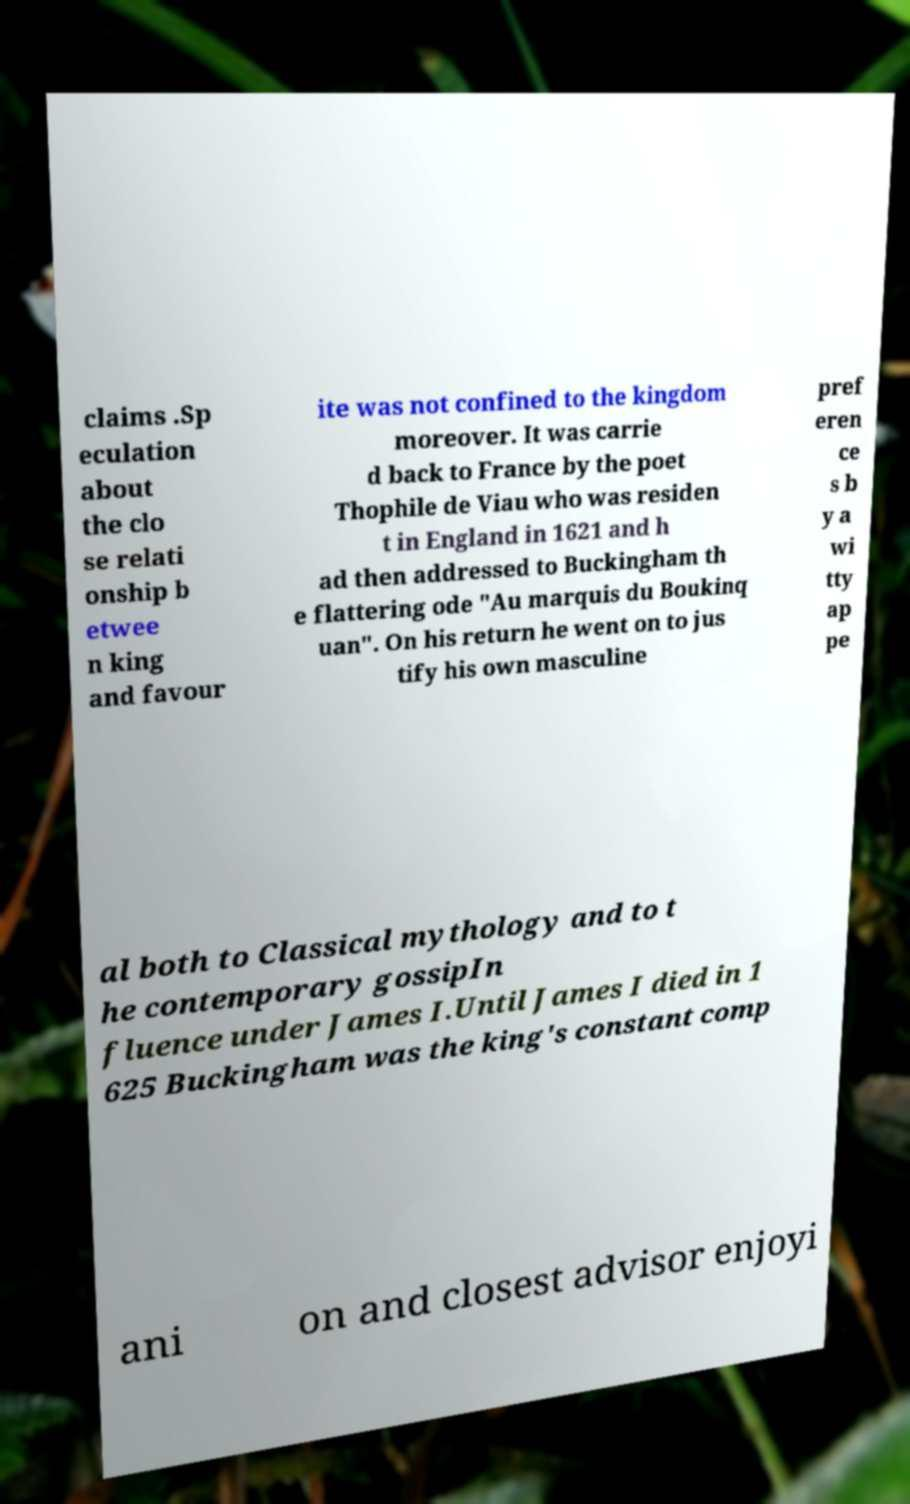For documentation purposes, I need the text within this image transcribed. Could you provide that? claims .Sp eculation about the clo se relati onship b etwee n king and favour ite was not confined to the kingdom moreover. It was carrie d back to France by the poet Thophile de Viau who was residen t in England in 1621 and h ad then addressed to Buckingham th e flattering ode "Au marquis du Boukinq uan". On his return he went on to jus tify his own masculine pref eren ce s b y a wi tty ap pe al both to Classical mythology and to t he contemporary gossipIn fluence under James I.Until James I died in 1 625 Buckingham was the king's constant comp ani on and closest advisor enjoyi 